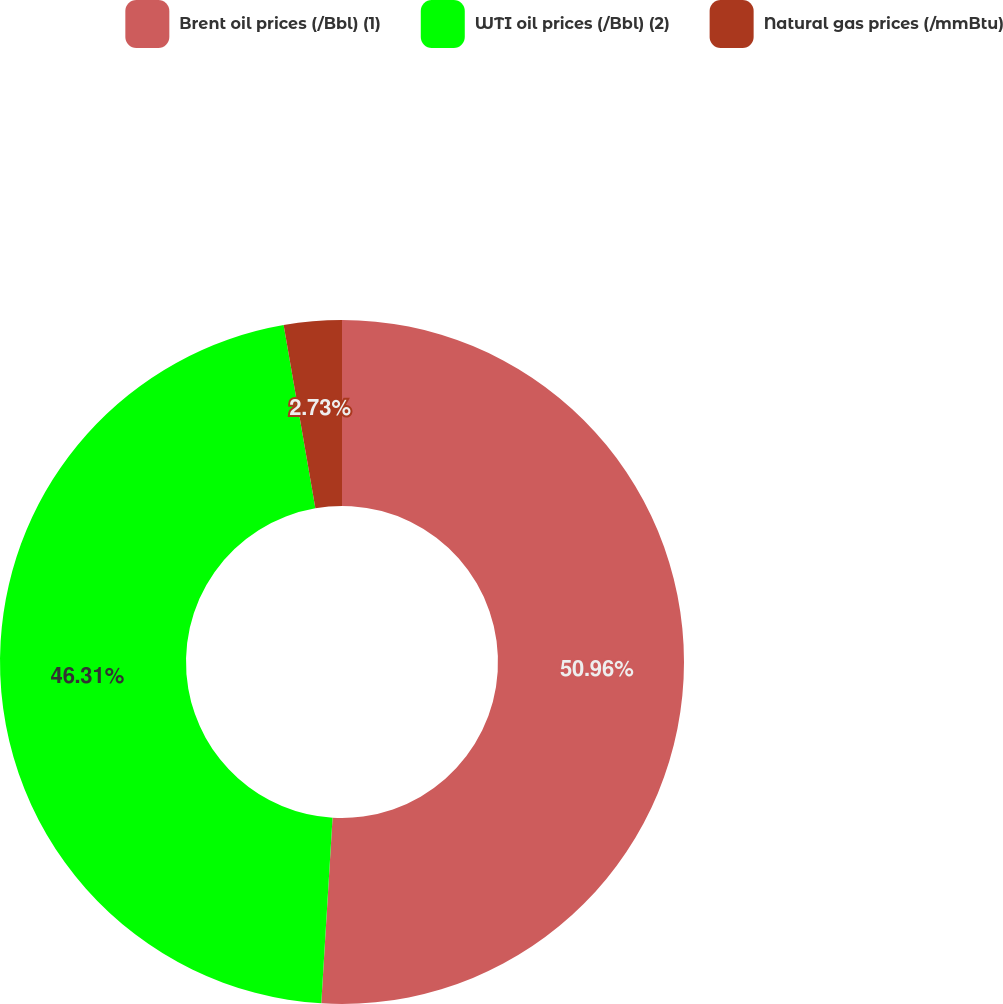Convert chart. <chart><loc_0><loc_0><loc_500><loc_500><pie_chart><fcel>Brent oil prices (/Bbl) (1)<fcel>WTI oil prices (/Bbl) (2)<fcel>Natural gas prices (/mmBtu)<nl><fcel>50.97%<fcel>46.31%<fcel>2.73%<nl></chart> 